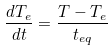<formula> <loc_0><loc_0><loc_500><loc_500>\frac { d T _ { e } } { d t } = \frac { T - T _ { e } } { t _ { e q } }</formula> 